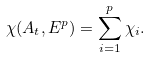<formula> <loc_0><loc_0><loc_500><loc_500>\chi ( A _ { t } , E ^ { p } ) = \sum _ { i = 1 } ^ { p } \chi _ { i } .</formula> 